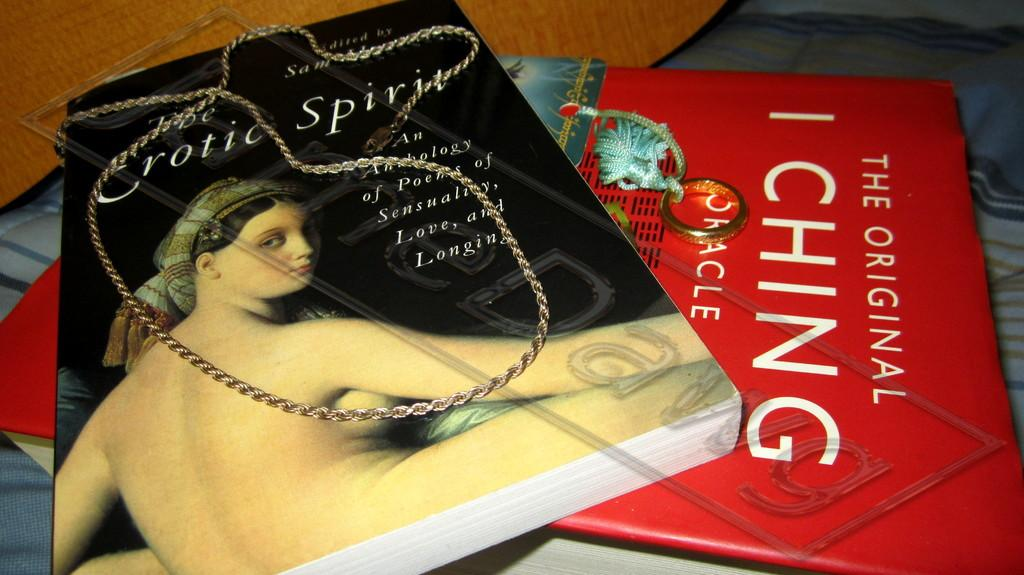<image>
Present a compact description of the photo's key features. 2 books with a red one titled the original ching 